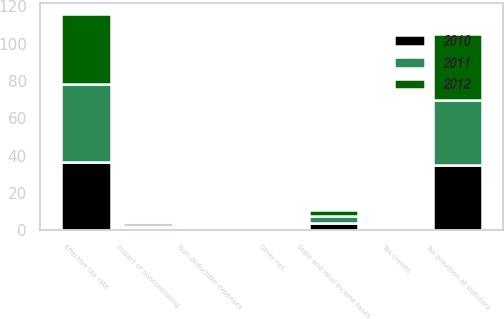Convert chart. <chart><loc_0><loc_0><loc_500><loc_500><stacked_bar_chart><ecel><fcel>Tax provision at statutory<fcel>State and local income taxes<fcel>Tax credits<fcel>Non-deductible expenses<fcel>Impact of noncontrolling<fcel>Other net<fcel>Effective tax rate<nl><fcel>2012<fcel>35<fcel>3.4<fcel>0.2<fcel>0.3<fcel>1.3<fcel>0.7<fcel>37.6<nl><fcel>2011<fcel>35<fcel>3.7<fcel>0.5<fcel>0.3<fcel>1.2<fcel>1<fcel>41.8<nl><fcel>2010<fcel>35<fcel>4<fcel>0.3<fcel>0.2<fcel>1.2<fcel>1.1<fcel>36.6<nl></chart> 